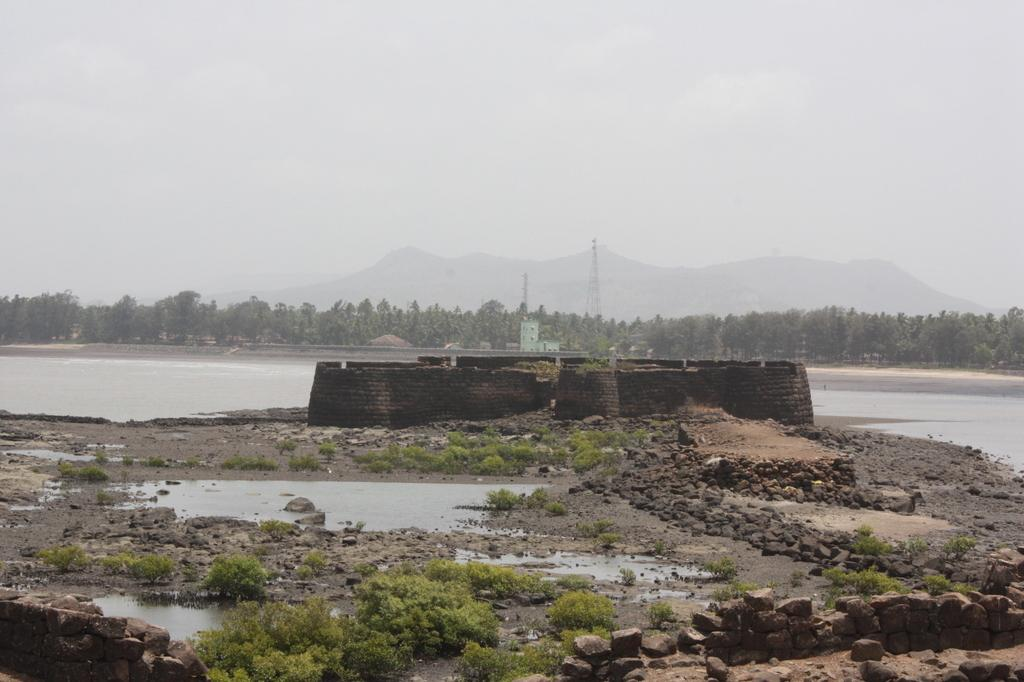What type of body of water is present in the image? There is a small water lake in the image. What structure can be seen in the middle of the lake? There is an old fort in the middle of the lake. What can be seen in the background of the image? There are many trees and mountains in the background of the image. What type of mint can be seen growing near the old fort in the image? There is no mint present in the image; it only features a small water lake, an old fort, trees, and mountains. 